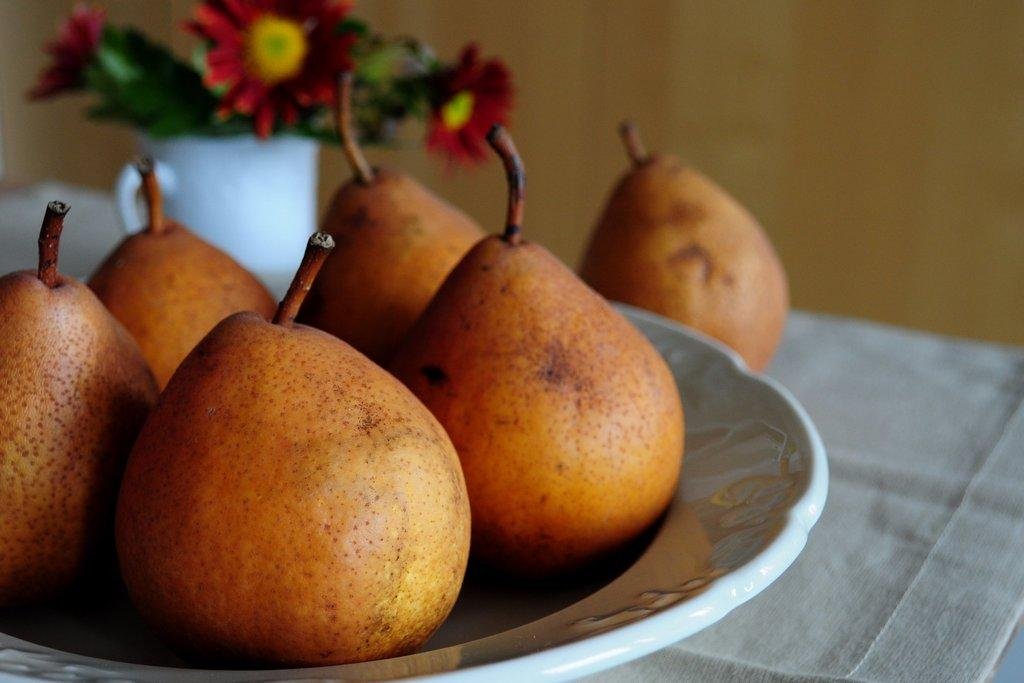What type of food items are on the table in the image? There are fruits on the table in the image. What is used for serving food on the table? There is a plate on the table. What decorative item can be seen on the table? There is a flower vase on the table. What is visible in the background of the image? There is a wall in the background of the image. What type of glass is being used to rest the fruits on the table? There is no glass present on the table in the image; the fruits are resting on the table itself. 